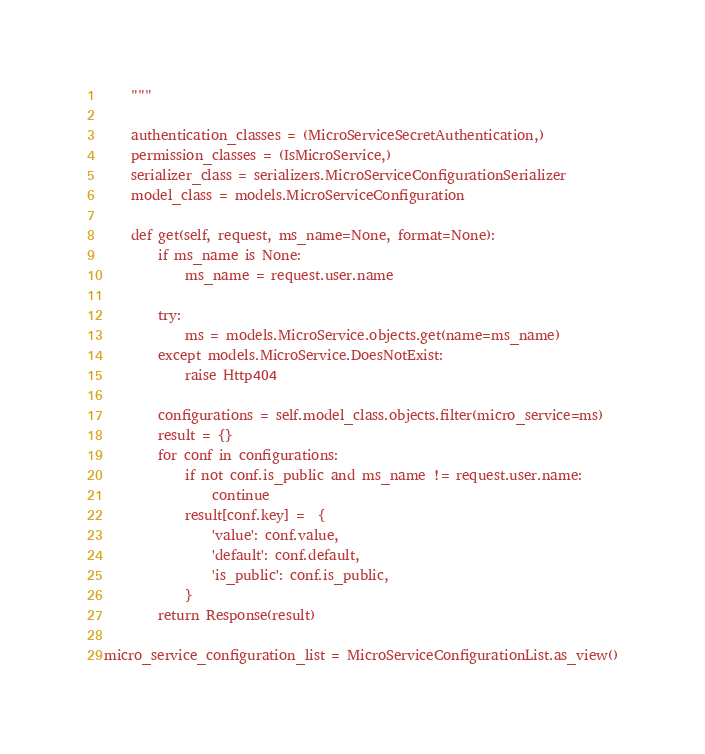<code> <loc_0><loc_0><loc_500><loc_500><_Python_>    """

    authentication_classes = (MicroServiceSecretAuthentication,)
    permission_classes = (IsMicroService,)
    serializer_class = serializers.MicroServiceConfigurationSerializer
    model_class = models.MicroServiceConfiguration

    def get(self, request, ms_name=None, format=None):
        if ms_name is None:
            ms_name = request.user.name

        try:
            ms = models.MicroService.objects.get(name=ms_name)
        except models.MicroService.DoesNotExist:
            raise Http404

        configurations = self.model_class.objects.filter(micro_service=ms)
        result = {}
        for conf in configurations:
            if not conf.is_public and ms_name != request.user.name:
                continue
            result[conf.key] =  {
                'value': conf.value,
                'default': conf.default,
                'is_public': conf.is_public,
            }
        return Response(result)

micro_service_configuration_list = MicroServiceConfigurationList.as_view()
</code> 